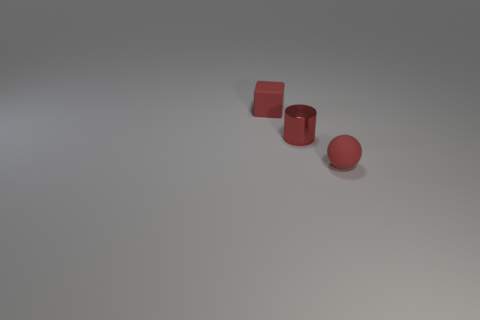Add 2 small brown shiny cylinders. How many objects exist? 5 Subtract all cubes. How many objects are left? 2 Subtract 1 spheres. How many spheres are left? 0 Subtract all gray cylinders. How many cyan cubes are left? 0 Subtract all tiny red balls. Subtract all matte blocks. How many objects are left? 1 Add 1 red metallic things. How many red metallic things are left? 2 Add 1 large blue rubber spheres. How many large blue rubber spheres exist? 1 Subtract 1 red cylinders. How many objects are left? 2 